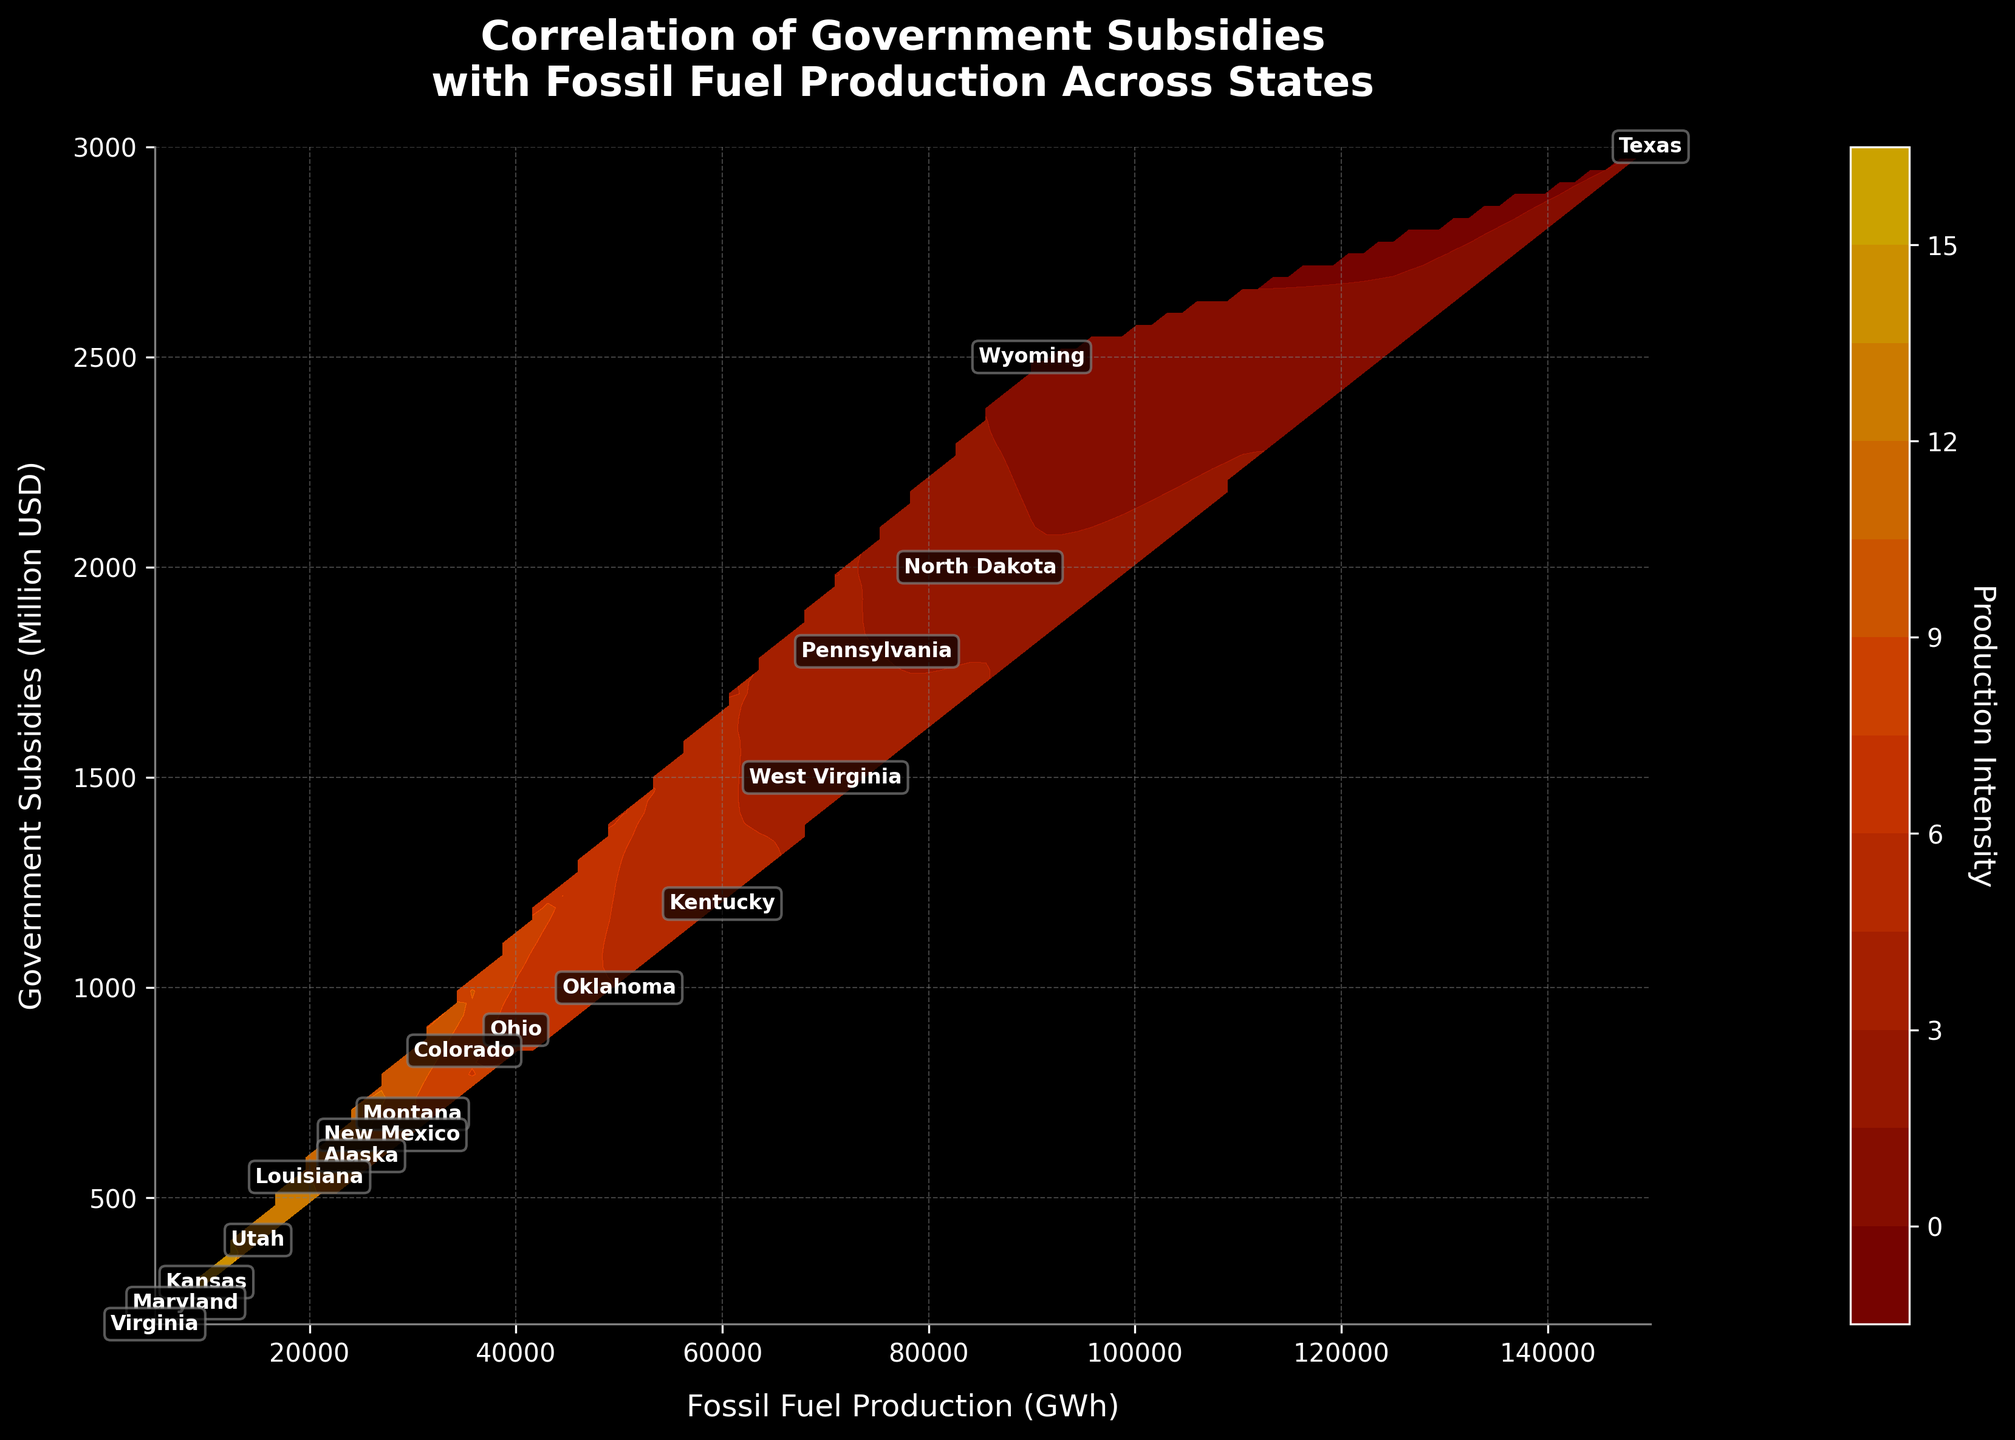What is the title of the figure? The title is placed at the top of the figure and is usually descriptive of what the plot represents. Here, the title is "Correlation of Government Subsidies with Fossil Fuel Production Across States".
Answer: Correlation of Government Subsidies with Fossil Fuel Production Across States What do the x-axis and y-axis represent in the figure? The axes labels describe what each axis represents. In this figure, the x-axis is labeled "Fossil Fuel Production (GWh)" and the y-axis is labeled "Government Subsidies (Million USD)".
Answer: Fossil Fuel Production (GWh) and Government Subsidies (Million USD) How many states are shown on the plot? The plot has labels for each data point representing a state. By counting these labels, we can determine that there are 17 states shown on the plot.
Answer: 17 Which state has the highest fossil fuel production and what is its corresponding government subsidy? By looking at the labels and their positions on the contour plot, the state with the highest fossil fuel production is Texas, with a production of 150,000 GWh and a government subsidy of 3,000 million USD.
Answer: Texas, 3,000 million USD Is there a general trend between fossil fuel production and government subsidies across the states? Observing the contour lines' gradients on the plot can provide insights into the relationship. Generally, states with higher fossil fuel production tend to receive higher government subsidies, suggesting a positive correlation.
Answer: Positive correlation Which state receives the lowest government subsidy and what is its corresponding fossil fuel production? By identifying the label of the lowest position on the y-axis, Virginia is the state with the lowest government subsidy of 200 million USD and a fossil fuel production of 5,000 GWh.
Answer: Virginia, 5,000 GWh What is the average amount of government subsidies provided to states with fossil fuel production below 30,000 GWh? First, identify the states below 30,000 GWh: Alaska, Louisiana, Utah, Kansas, Maryland, and Virginia. Sum their subsidies (600 + 550 + 400 + 300 + 250 + 200 = 2,300 million USD) and divide by the number of states (2,300/6).
Answer: 383.33 million USD Which states fall within the highest production intensity based on the contour coloring? The highest production intensity is indicated by the darkest red region of the contour plot. The states within this region are Texas, Wyoming, and North Dakota.
Answer: Texas, Wyoming, North Dakota How does the government subsidy for Pennsylvania compare to that of Ohio? By identifying the labels for Pennsylvania and Ohio on the plot, Pennsylvania has a subsidy of 1,800 million USD, while Ohio has 900 million USD. Pennsylvania receives twice the subsidy amount as Ohio.
Answer: Pennsylvania has higher subsidies than Ohio What is the production intensity color scale, and how is it represented on the plot? The production intensity is shown using a color gradient, ranging from dark red (high intensity) to yellow (low intensity). This is depicted by the color bar on the side of the plot.
Answer: Dark red to yellow color gradient 